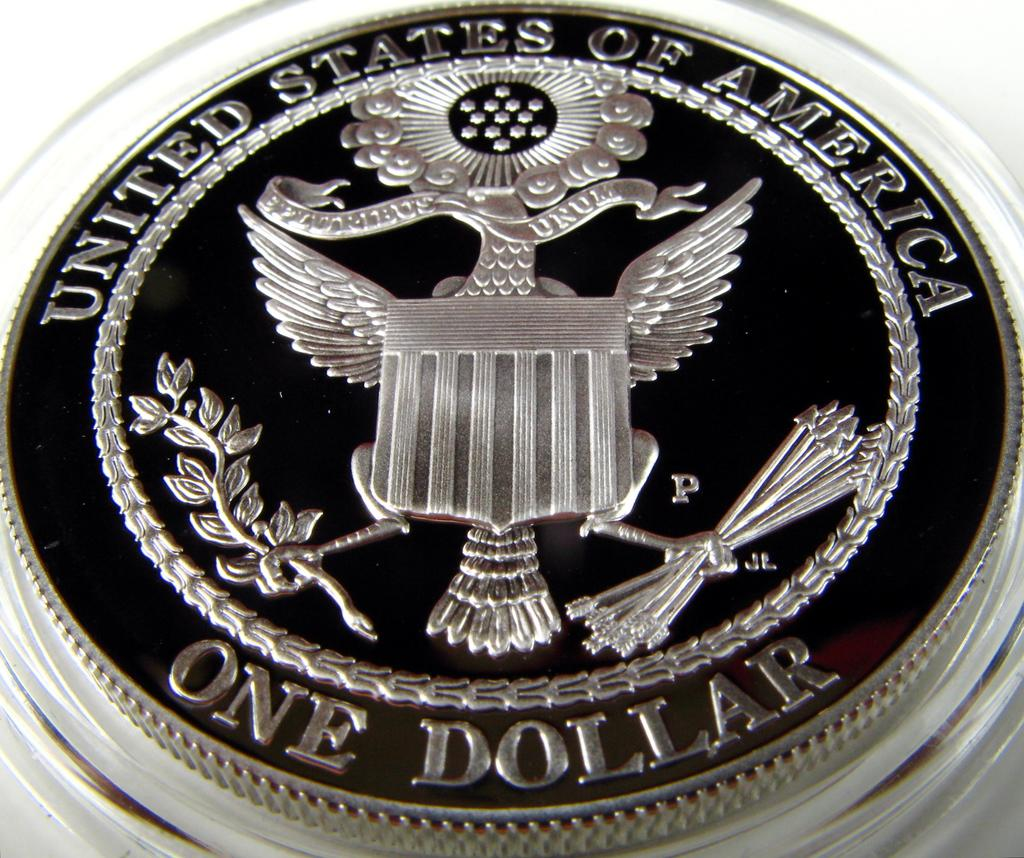<image>
Render a clear and concise summary of the photo. A shiny United States of America one dollar coin. 